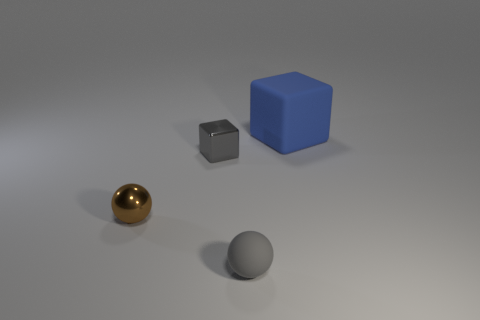What material is the tiny thing on the right side of the cube that is on the left side of the blue thing?
Your answer should be compact. Rubber. Is the color of the cube that is on the left side of the gray matte ball the same as the matte cube?
Provide a succinct answer. No. Is there anything else that is the same material as the tiny cube?
Make the answer very short. Yes. What number of metallic things are the same shape as the large blue rubber object?
Offer a terse response. 1. What is the size of the cube that is the same material as the small brown object?
Provide a succinct answer. Small. There is a gray thing that is behind the gray object on the right side of the shiny cube; is there a tiny gray metal object to the left of it?
Your answer should be compact. No. Do the cube on the left side of the gray matte object and the blue rubber cube have the same size?
Your answer should be compact. No. What number of brown balls are the same size as the gray block?
Ensure brevity in your answer.  1. What is the size of the sphere that is the same color as the small cube?
Provide a succinct answer. Small. Is the large rubber cube the same color as the small shiny cube?
Offer a terse response. No. 